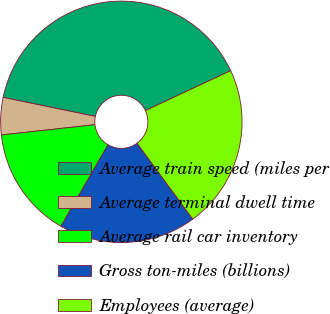<chart> <loc_0><loc_0><loc_500><loc_500><pie_chart><fcel>Average train speed (miles per<fcel>Average terminal dwell time<fcel>Average rail car inventory<fcel>Gross ton-miles (billions)<fcel>Employees (average)<nl><fcel>39.8%<fcel>4.98%<fcel>14.93%<fcel>18.41%<fcel>21.89%<nl></chart> 